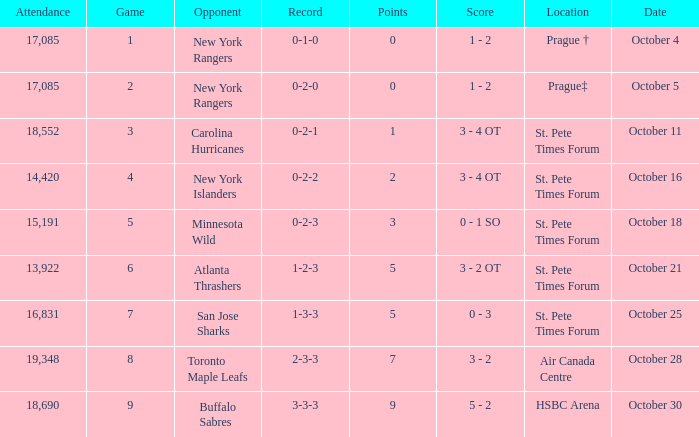What was the attendance when their record stood at 0-2-2? 14420.0. 